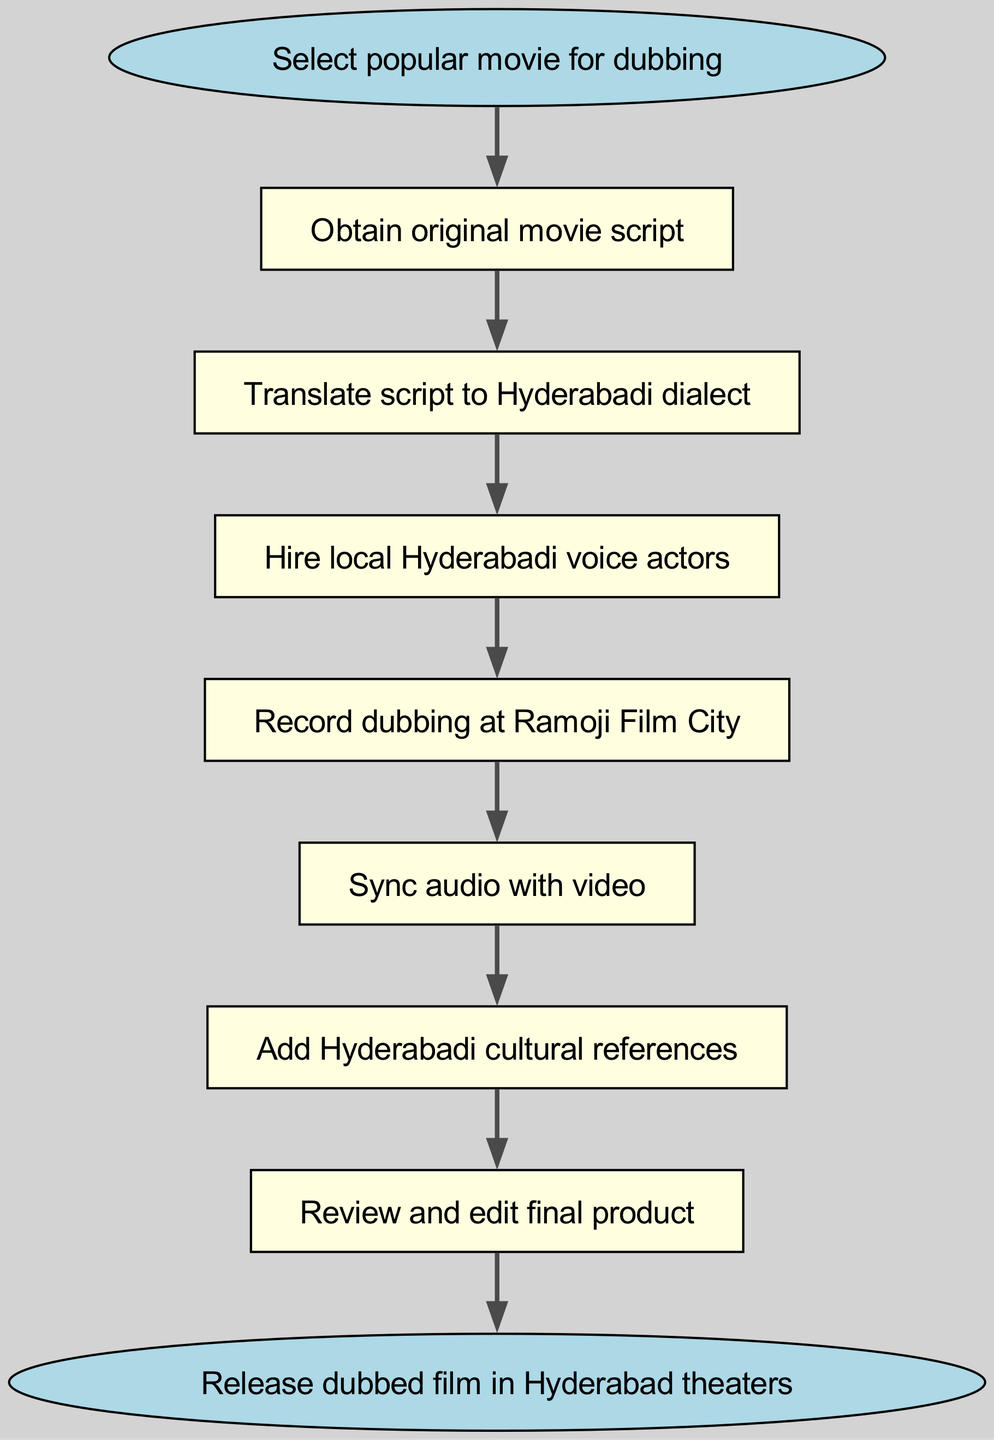What is the first step in the dubbing process? The first step in the process begins from the "start" node, which leads to "Obtain original movie script." Therefore, the first step is to obtain the original movie script.
Answer: Obtain original movie script How many steps are there in total? By counting the nodes in the diagram, there are 8 steps from the start to the end; therefore, the process consists of 8 steps.
Answer: 8 What step involves Hyderabadi cultural references? The step that includes Hyderabadi cultural references is "Add Hyderabadi cultural references," which follows the audio syncing step.
Answer: Add Hyderabadi cultural references Which step follows hiring local Hyderabadi voice actors? After hiring local Hyderabadi voice actors, the following step is to "Record dubbing at Ramoji Film City," as indicated by the connection in the diagram.
Answer: Record dubbing at Ramoji Film City What is the last step before releasing the film? The last step before releasing the film is "Review and edit final product," which directly comes before the end node that indicates the film's release.
Answer: Review and edit final product Which step comes after syncing audio with video? The step that follows "Sync audio with video" is "Add Hyderabadi cultural references" according to the directional flow in the diagram.
Answer: Add Hyderabadi cultural references What is the transition from translating the script? The transition from "Translate script to Hyderabadi dialect" leads to "Hire local Hyderabadi voice actors," showing a sequential flow in the dubbing process.
Answer: Hire local Hyderabadi voice actors What step occurs immediately after recording at Ramoji Film City? Immediately after "Record dubbing at Ramoji Film City," the next step is to "Sync audio with video," completing the recording process.
Answer: Sync audio with video 